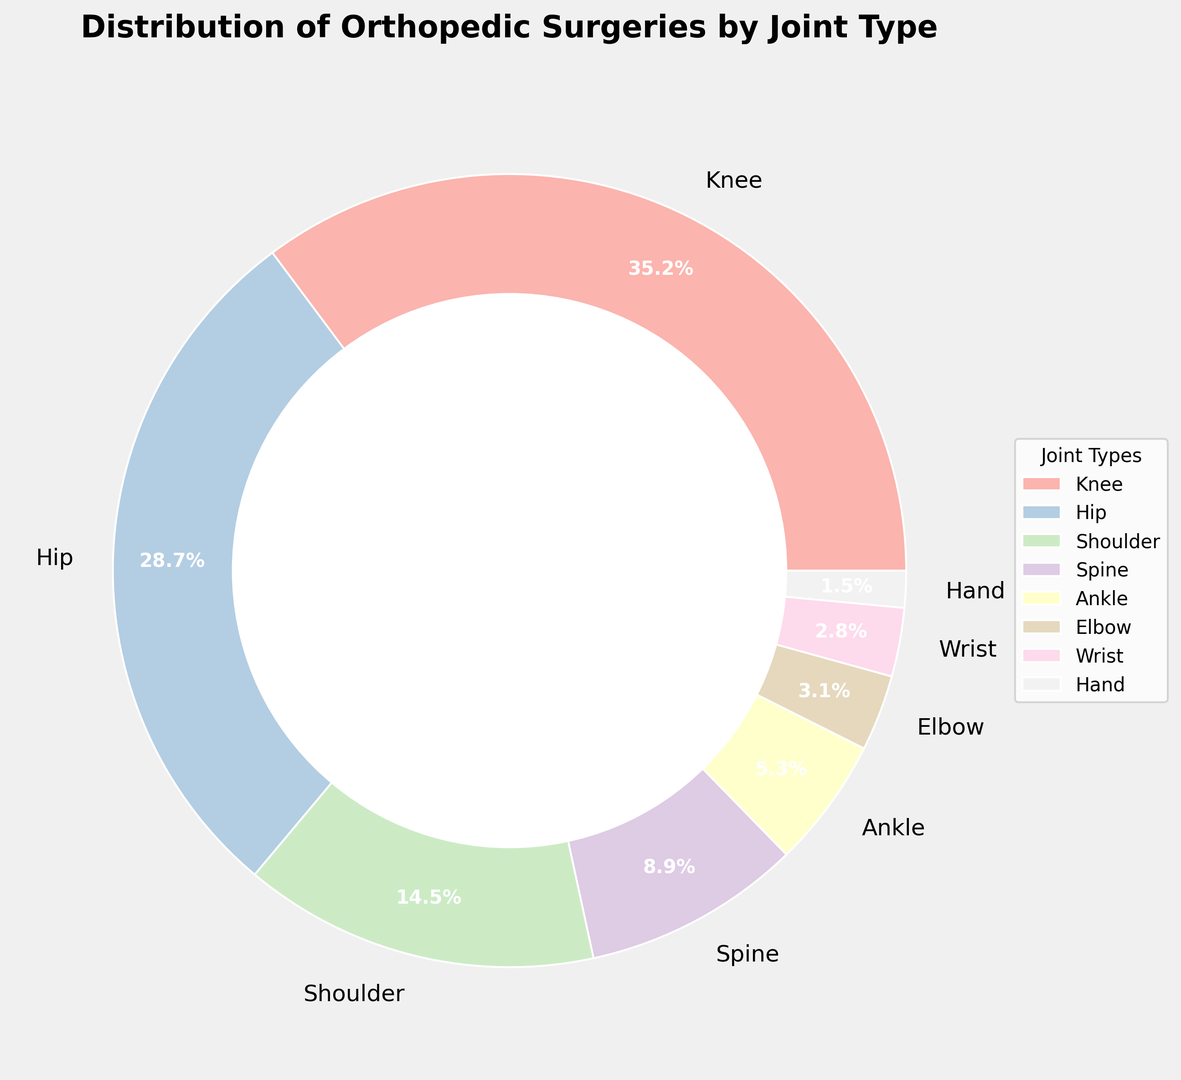What joint type has the highest percentage of surgeries? The largest segment in the ring chart is for knee surgeries, which represents 35.2% of the total surgeries.
Answer: Knee Which joint type has the lowest percentage of surgeries? The smallest segment in the ring chart corresponds to hand surgeries, which accounts for 1.5% of the total surgeries.
Answer: Hand How much greater is the percentage of knee surgeries compared to hip surgeries? The knee surgeries make up 35.2% while hip surgeries make up 28.7%. The difference is 35.2% - 28.7% = 6.5%.
Answer: 6.5% What is the total percentage of surgeries for knee, hip, and shoulder joints combined? Adding the percentages of the knee, hip, and shoulder categories: 35.2% + 28.7% + 14.5% = 78.4%.
Answer: 78.4% By how much percentage do shoulder surgeries exceed spine surgeries? Shoulder surgeries account for 14.5% and spine surgeries account for 8.9%. The difference is 14.5% - 8.9% = 5.6%.
Answer: 5.6% How many joint types are represented with percentages less than 10%? By examining the chart, the joint types with percentages less than 10% are Spine, Ankle, Elbow, Wrist, and Hand. Therefore, there are 5 joint types.
Answer: 5 How much more common are ankle surgeries than elbow surgeries? The percentage for ankle surgeries is 5.3% while for elbow surgeries it’s 3.1%. The difference is 5.3% - 3.1% = 2.2%.
Answer: 2.2% What percentage do wrist and hand surgeries together represent? Adding the percentages for wrist and hand surgeries: 2.8% + 1.5% = 4.3%.
Answer: 4.3% Which joint types have percentages closest to each other? Examining the segments, elbow surgeries (3.1%) and wrist surgeries (2.8%) have the smallest difference, which is 3.1% - 2.8% = 0.3%.
Answer: Elbow and Wrist What is the average percentage of surgeries for hip, shoulder, and spine joints? Adding the percentages: 28.7% (hip) + 14.5% (shoulder) + 8.9% (spine) = 52.1%, dividing by 3 gives the average, 52.1 / 3 = 17.37%.
Answer: 17.37% 